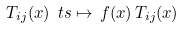Convert formula to latex. <formula><loc_0><loc_0><loc_500><loc_500>T _ { i j } ( x ) \ t s \mapsto \, f ( x ) \, T _ { i j } ( x )</formula> 